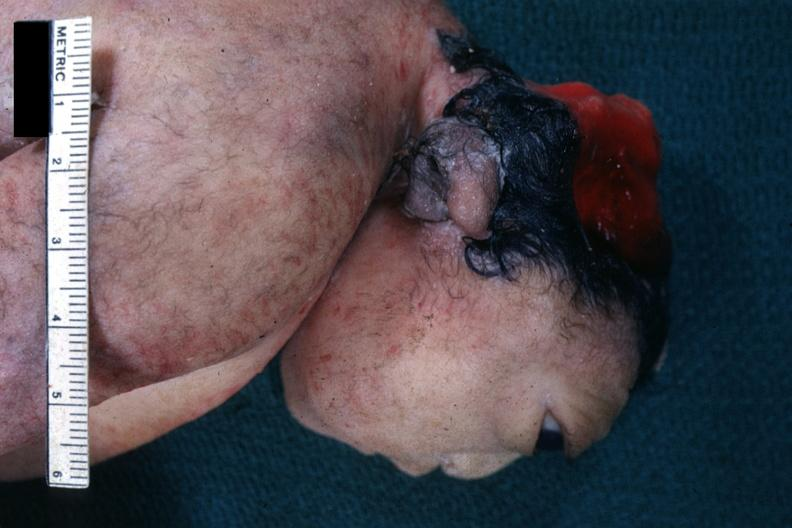does this image show lateral view of head typical example?
Answer the question using a single word or phrase. Yes 